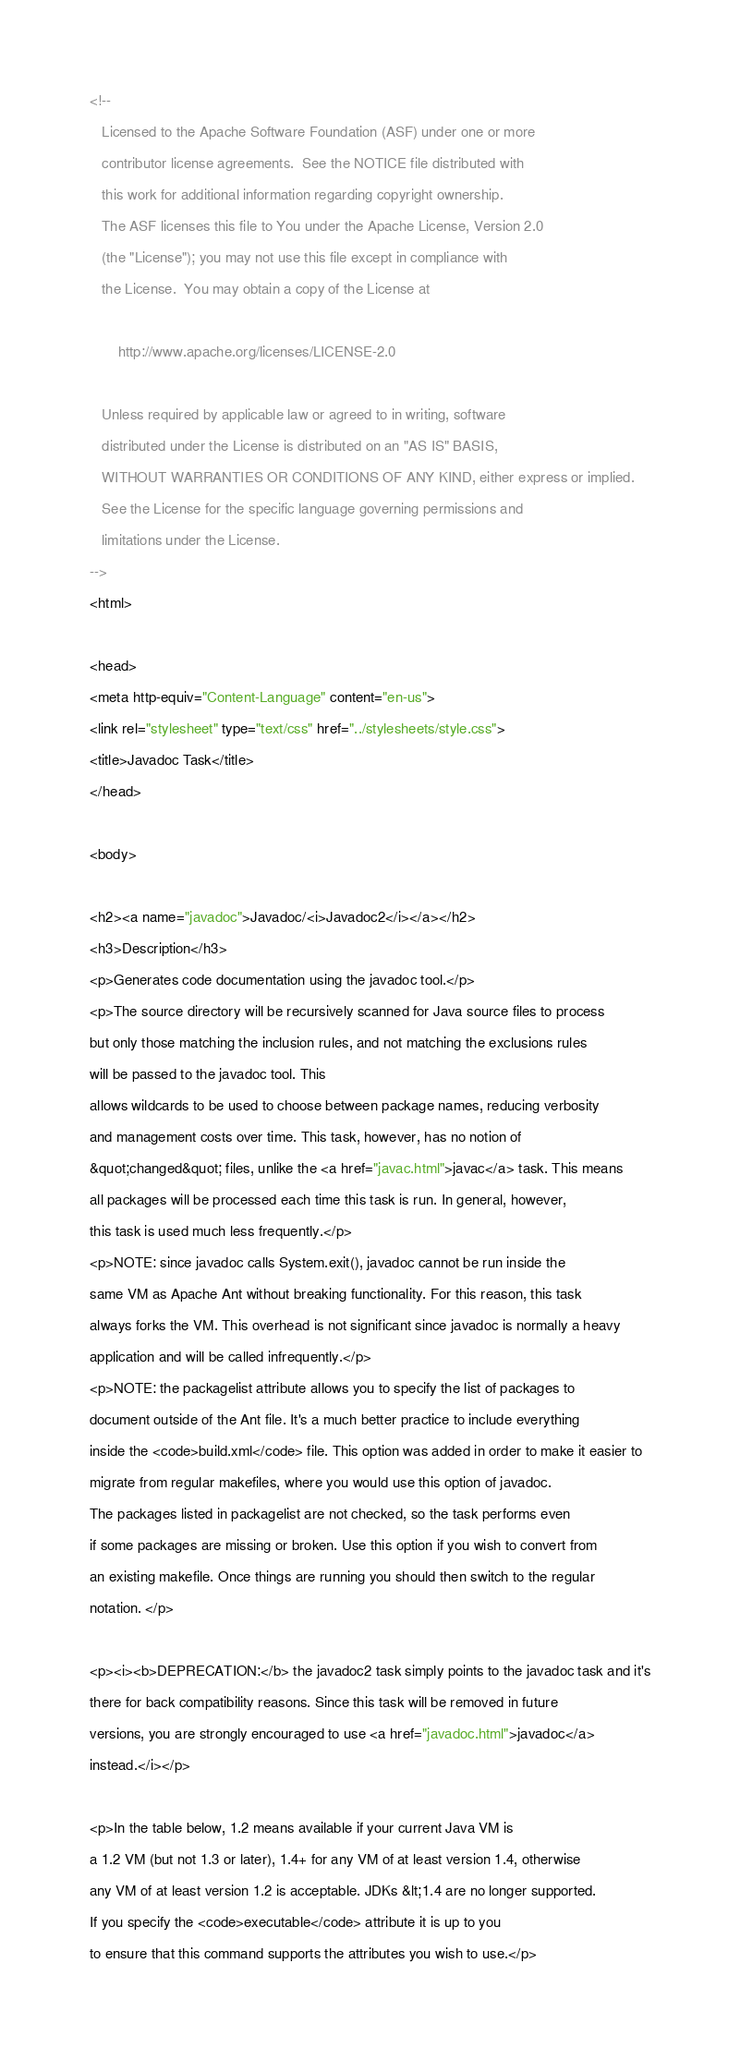<code> <loc_0><loc_0><loc_500><loc_500><_HTML_><!--
   Licensed to the Apache Software Foundation (ASF) under one or more
   contributor license agreements.  See the NOTICE file distributed with
   this work for additional information regarding copyright ownership.
   The ASF licenses this file to You under the Apache License, Version 2.0
   (the "License"); you may not use this file except in compliance with
   the License.  You may obtain a copy of the License at

       http://www.apache.org/licenses/LICENSE-2.0

   Unless required by applicable law or agreed to in writing, software
   distributed under the License is distributed on an "AS IS" BASIS,
   WITHOUT WARRANTIES OR CONDITIONS OF ANY KIND, either express or implied.
   See the License for the specific language governing permissions and
   limitations under the License.
-->
<html>

<head>
<meta http-equiv="Content-Language" content="en-us">
<link rel="stylesheet" type="text/css" href="../stylesheets/style.css">
<title>Javadoc Task</title>
</head>

<body>

<h2><a name="javadoc">Javadoc/<i>Javadoc2</i></a></h2>
<h3>Description</h3>
<p>Generates code documentation using the javadoc tool.</p>
<p>The source directory will be recursively scanned for Java source files to process
but only those matching the inclusion rules, and not matching the exclusions rules
will be passed to the javadoc tool. This
allows wildcards to be used to choose between package names, reducing verbosity
and management costs over time. This task, however, has no notion of
&quot;changed&quot; files, unlike the <a href="javac.html">javac</a> task. This means
all packages will be processed each time this task is run. In general, however,
this task is used much less frequently.</p>
<p>NOTE: since javadoc calls System.exit(), javadoc cannot be run inside the
same VM as Apache Ant without breaking functionality. For this reason, this task
always forks the VM. This overhead is not significant since javadoc is normally a heavy
application and will be called infrequently.</p>
<p>NOTE: the packagelist attribute allows you to specify the list of packages to
document outside of the Ant file. It's a much better practice to include everything
inside the <code>build.xml</code> file. This option was added in order to make it easier to
migrate from regular makefiles, where you would use this option of javadoc.
The packages listed in packagelist are not checked, so the task performs even
if some packages are missing or broken. Use this option if you wish to convert from
an existing makefile. Once things are running you should then switch to the regular
notation. </p>

<p><i><b>DEPRECATION:</b> the javadoc2 task simply points to the javadoc task and it's
there for back compatibility reasons. Since this task will be removed in future
versions, you are strongly encouraged to use <a href="javadoc.html">javadoc</a>
instead.</i></p>

<p>In the table below, 1.2 means available if your current Java VM is
a 1.2 VM (but not 1.3 or later), 1.4+ for any VM of at least version 1.4, otherwise
any VM of at least version 1.2 is acceptable. JDKs &lt;1.4 are no longer supported.
If you specify the <code>executable</code> attribute it is up to you
to ensure that this command supports the attributes you wish to use.</p>
</code> 